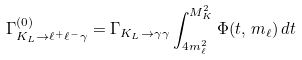<formula> <loc_0><loc_0><loc_500><loc_500>\Gamma _ { K _ { L } \rightarrow \ell ^ { + } \ell ^ { - } \gamma } ^ { ( 0 ) } = \Gamma _ { K _ { L } \rightarrow \gamma \gamma } \int _ { 4 m _ { \ell } ^ { 2 } } ^ { M _ { K } ^ { 2 } } \Phi ( t , \, m _ { \ell } ) \, d t</formula> 